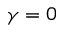<formula> <loc_0><loc_0><loc_500><loc_500>\gamma = 0</formula> 